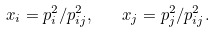<formula> <loc_0><loc_0><loc_500><loc_500>x _ { i } = p _ { i } ^ { 2 } / p _ { i j } ^ { 2 } , \quad x _ { j } = p _ { j } ^ { 2 } / p _ { i j } ^ { 2 } .</formula> 